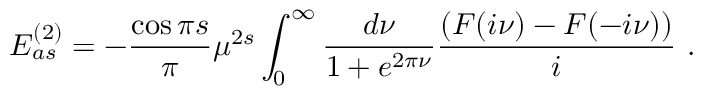<formula> <loc_0><loc_0><loc_500><loc_500>E _ { a s } ^ { ( 2 ) } = - { \frac { \cos { \pi s } } { \pi } } \mu ^ { 2 s } \int _ { 0 } ^ { \infty } \frac { d \nu } { 1 + e ^ { 2 \pi \nu } } \frac { ( F ( i \nu ) - F ( - i \nu ) ) } { i } \ .</formula> 